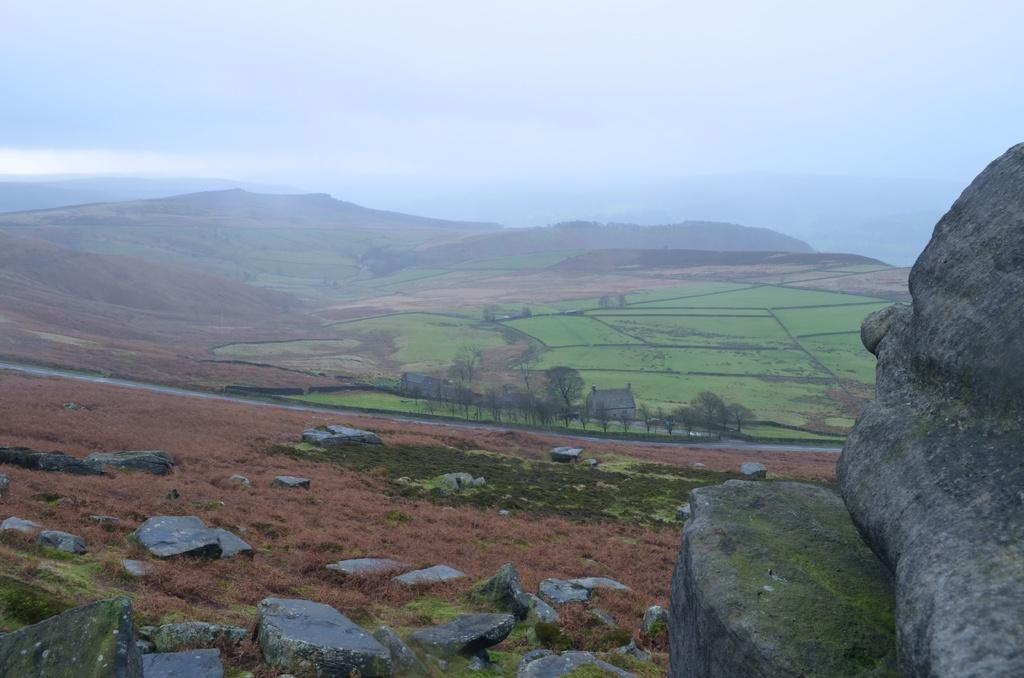What type of natural formations can be seen in the image? There are huge rocks and stones visible in the image. What type of vegetation can be seen in the image? There are crops visible in the image. What is visible in the background of the image? There are mountains in the background of the image. How many trees are growing on the knee of the person in the image? There is no person present in the image, and therefore no knee or trees growing on it. 